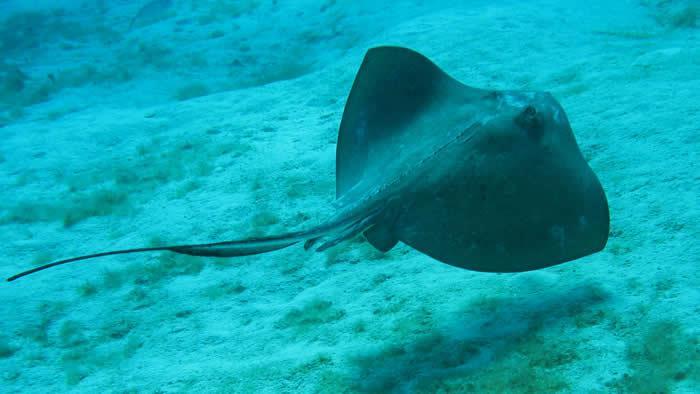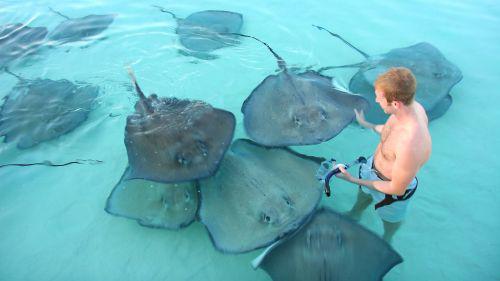The first image is the image on the left, the second image is the image on the right. For the images shown, is this caption "You can see the underside of the ray." true? Answer yes or no. No. The first image is the image on the left, the second image is the image on the right. Analyze the images presented: Is the assertion "Each image has exactly one ray." valid? Answer yes or no. No. 